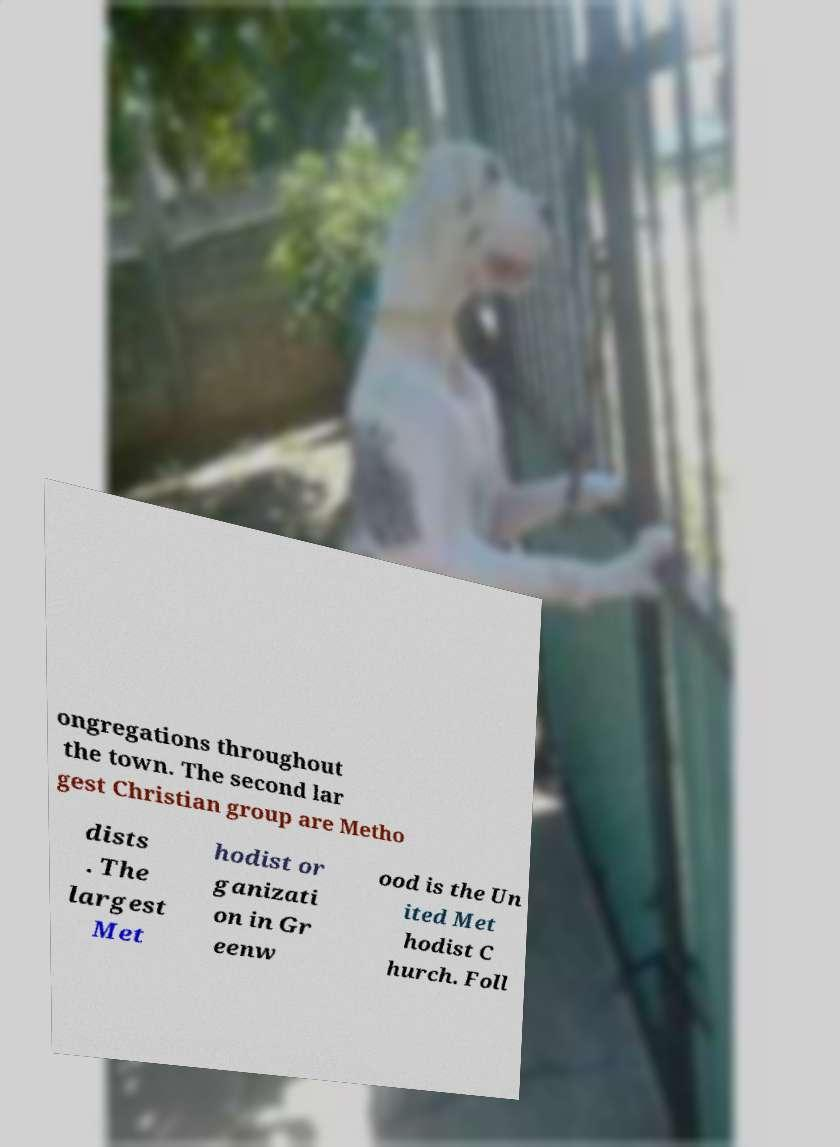Can you accurately transcribe the text from the provided image for me? ongregations throughout the town. The second lar gest Christian group are Metho dists . The largest Met hodist or ganizati on in Gr eenw ood is the Un ited Met hodist C hurch. Foll 